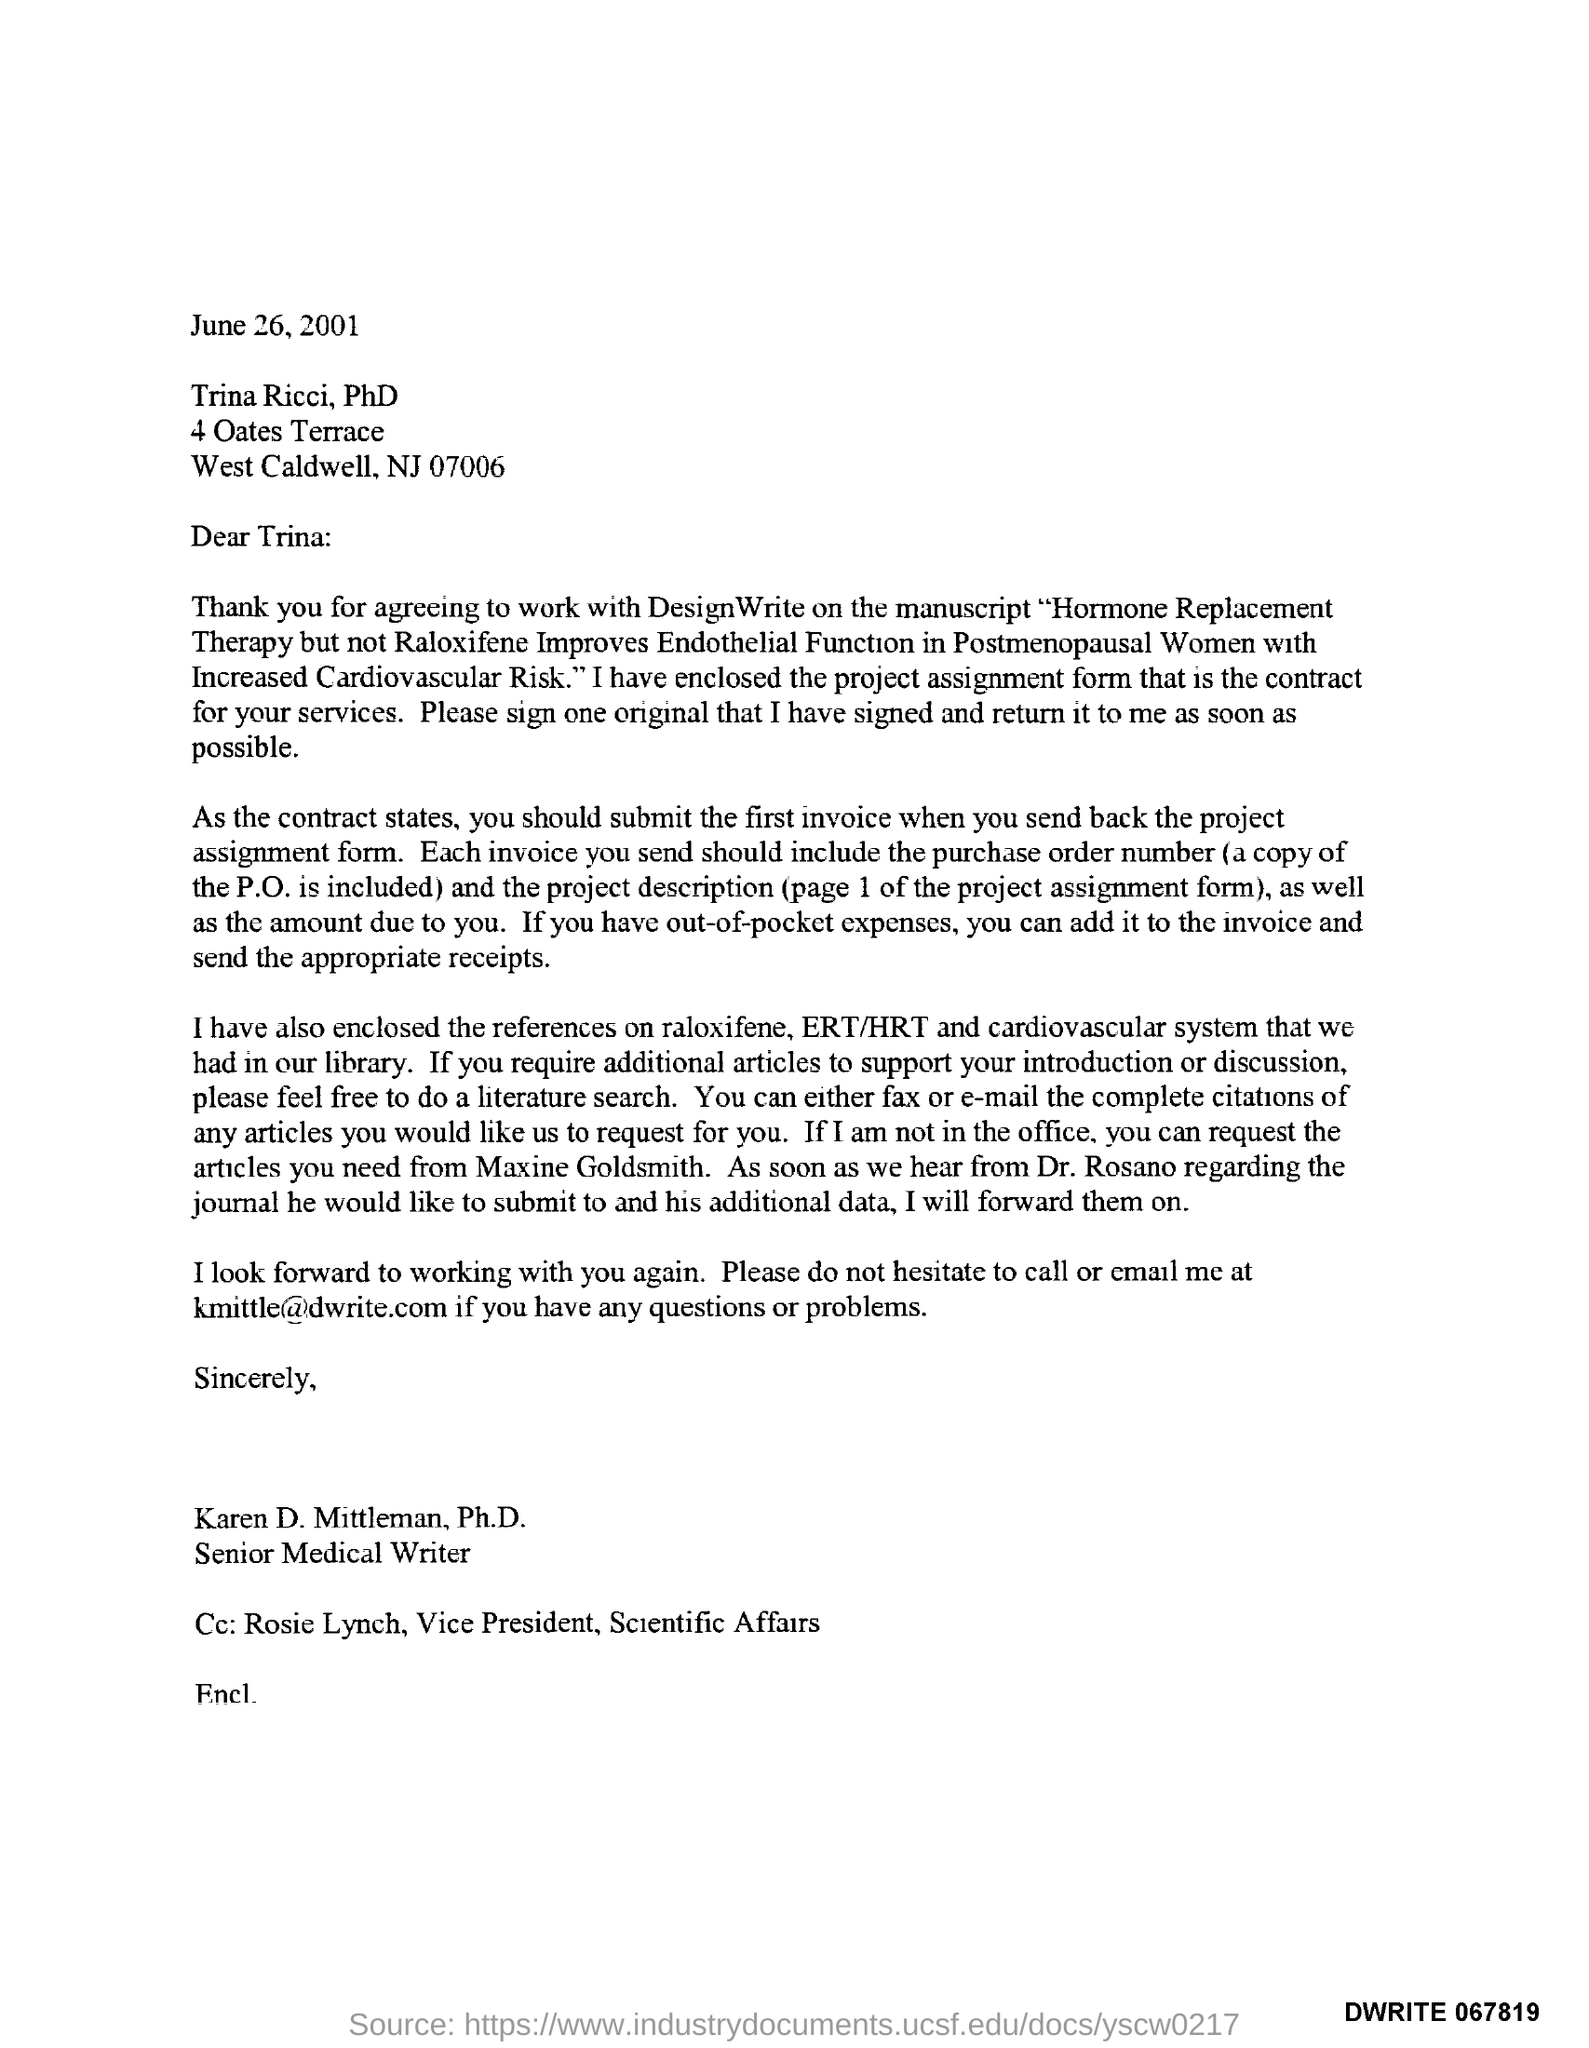Identify some key points in this picture. The date mentioned in this letter is June 26, 2001. The recipient of this letter has been marked as Rosie Lynch, the Vice President of Scientific Affairs. The letter is sent by Karen D. Mittleman, Ph.D. Karen D. Mittleman, Ph.D., is a senior medical writer. Karen D. Mittleman, Ph.D. can be reached at the email address [kmittle@dwrite.com](mailto:kmittle@dwrite.com). 